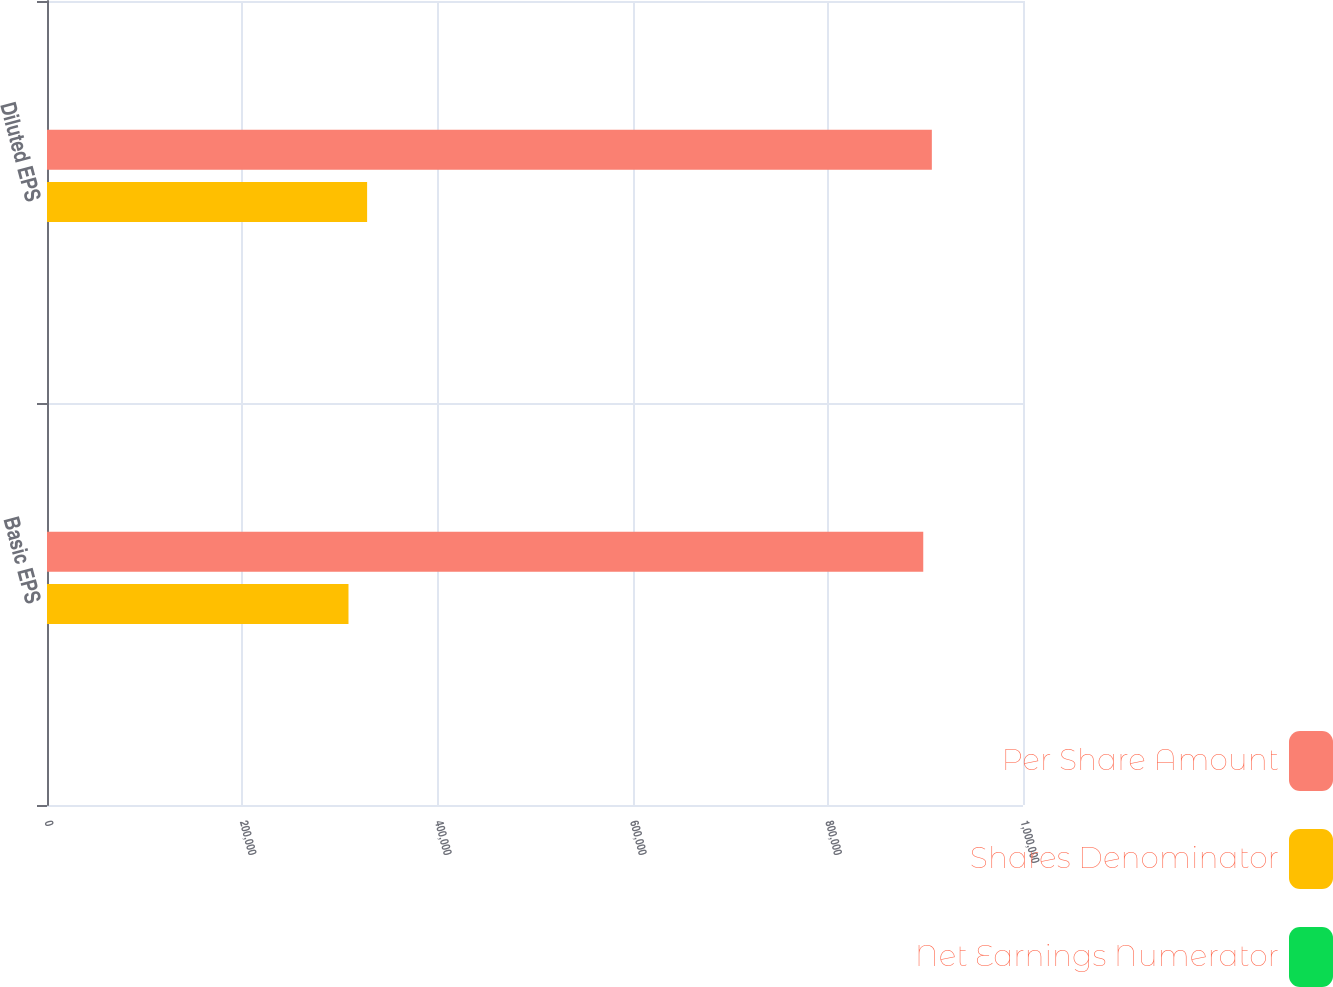<chart> <loc_0><loc_0><loc_500><loc_500><stacked_bar_chart><ecel><fcel>Basic EPS<fcel>Diluted EPS<nl><fcel>Per Share Amount<fcel>897800<fcel>906602<nl><fcel>Shares Denominator<fcel>308905<fcel>327983<nl><fcel>Net Earnings Numerator<fcel>2.91<fcel>2.76<nl></chart> 